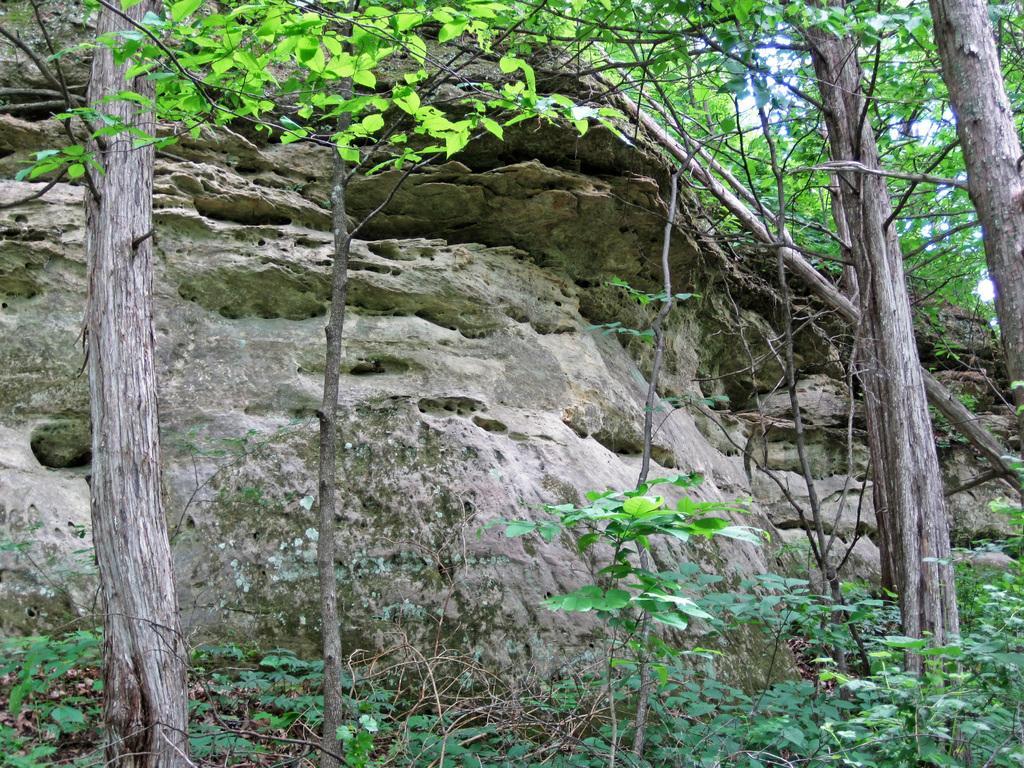Could you give a brief overview of what you see in this image? This picture is taken from the forest. In this image, we can see some trees and plants, we can also see some wooden rod. In the background, we can see some rocks. At the top, we can see a sky, at the bottom, we can see some plants and a grass. 